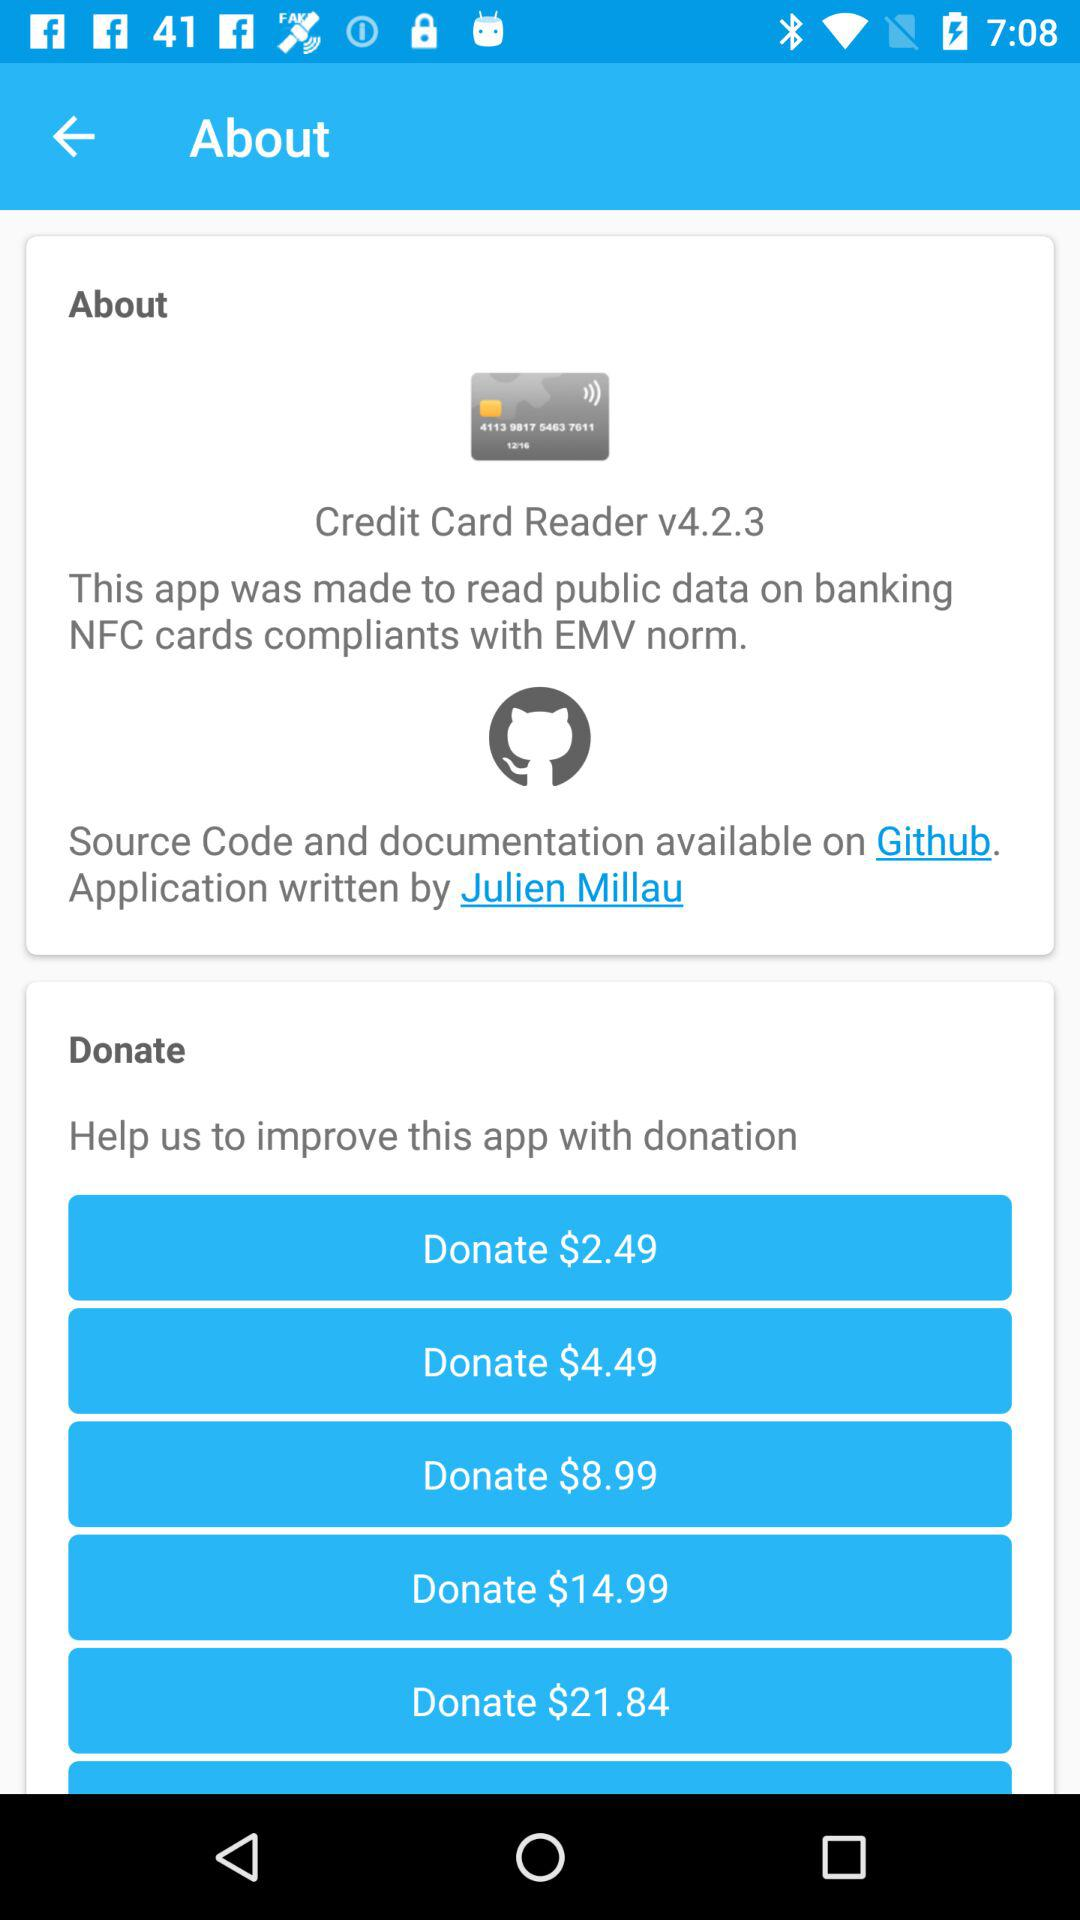Who has written the application? The application is written by Julien Millau. 